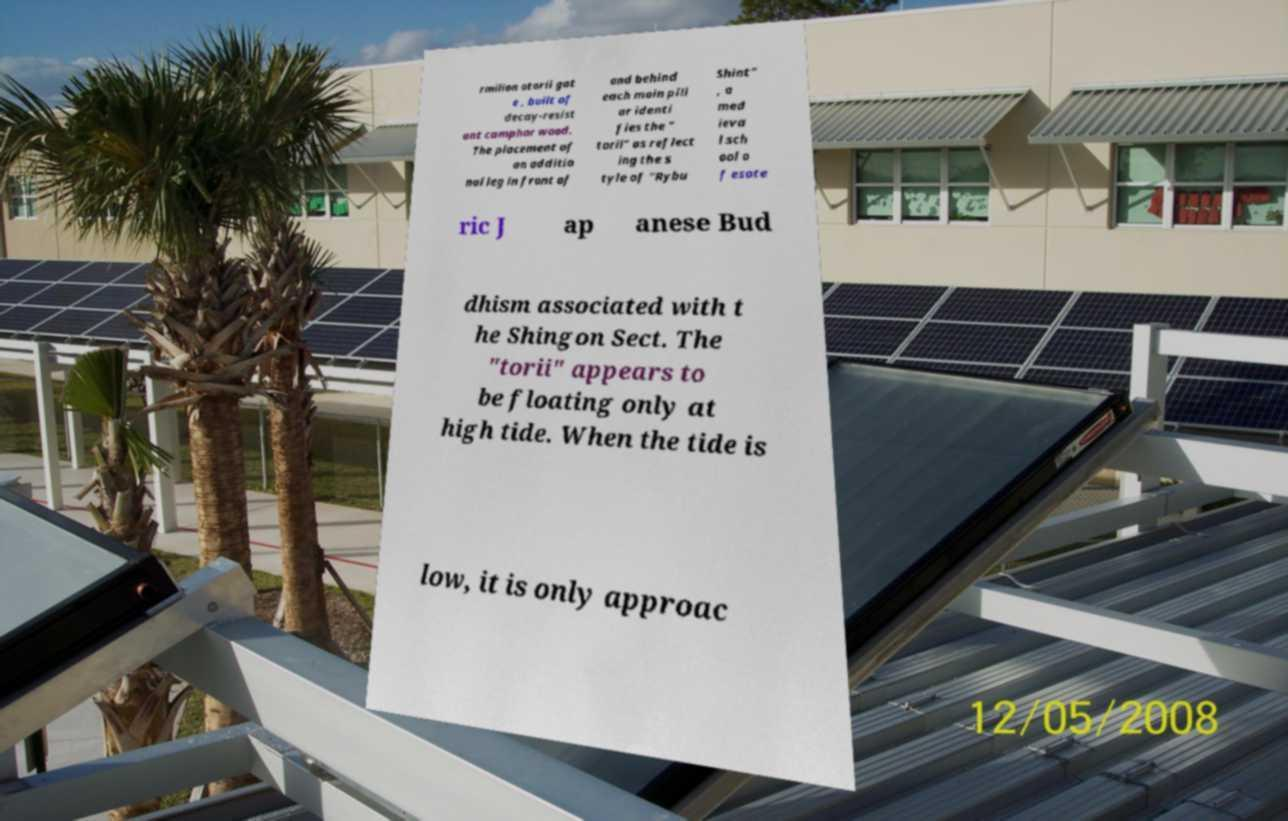There's text embedded in this image that I need extracted. Can you transcribe it verbatim? rmilion otorii gat e , built of decay-resist ant camphor wood. The placement of an additio nal leg in front of and behind each main pill ar identi fies the " torii" as reflect ing the s tyle of "Rybu Shint" , a med ieva l sch ool o f esote ric J ap anese Bud dhism associated with t he Shingon Sect. The "torii" appears to be floating only at high tide. When the tide is low, it is only approac 